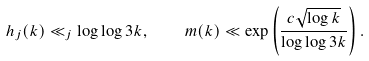<formula> <loc_0><loc_0><loc_500><loc_500>h _ { j } ( k ) \ll _ { j } \log \log 3 k , \quad m ( k ) \ll \exp \left ( \frac { c \sqrt { \log k } } { \log \log 3 k } \right ) .</formula> 